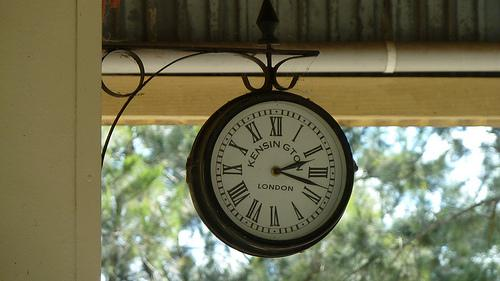Can you count how many objects are at the scene? What are they? There are 4 objects: a black clock with Roman numerals, a white wall, a white pipe, and green leaves in the background. What type of clock is in the image, and what is its color? It's a black clock with Roman numerals and "Kensington London" written on it. Describe the scene around the clock. There is a white wall with a wood beam, a hanging clock with roman numerals, a white pipe against the wall, and a forest area with green leaves in the background. What is the color of the wall, and what object is leaning against it? The wall is white, and a white pipe is leaning against it. Explain the position and characteristics of the clock's hands. The clock has black hands, with a small hour handle and a large minute handle. Identify the type of numeral system used on the clock. The clock uses Roman numerals. Provide a description of the primary object in the image. A black clock with roman numerals and "Kensington London" written on it is hanging on a white wall. What is unusual about the numbers on the clock and their placement? They are Roman numerals, and they are not placed in a perfect circle. How does the clock appear to be attached to the wall? The clock is attached to the wall using a metal display arm. Where are the green leaves located? The green leaves are located in the forest area in the background of the image. Describe the type of clock in the image. A hanging clock What is the color combination of the clock? Brown and white Identify the color of the leaves in the background. Green Can you see a digital clock in the image? The image describes a clock with roman numerals, which means it is an analog clock. Mentioning a digital clock is misleading. Can you find any animals in the forest area of the image? No, it's not mentioned in the image. Describe the color and type of numerals on the clock. The clock has black Roman numerals. Which objects are found against the wall? A clock and a white pipe How many clock hands are mentioned in the image captions? Two (little hand and big hand) List the different types of numerals mentioned on the clock face. XII, VI, III, IX, X In the image, where is the clock positioned? Attached to the wall Describe the wall where the clock is hanging. The wall is white. Which part of the clock is made of metal? Clock display arm What does the clock say? Kensington London What type of hands does the clock have? Provide a brief description. The clock has a small hour hand and a large minute hand, both black. Describe the clock's appearance. It is a black and white clock with Roman numerals, hanging on a white wall. The hands are black and it says Kensington London. Describe the surroundings of the clock in the image. A white wall, a wood beam, and a forest area with green leaves. What is unique about the numerals on the clock? The numerals are Roman. Provide a brief description of the forest area in the background of the image. The forest area has green leaves. Which statement is true about the clock? b) The clock is white  What type of numeral represents 3 on the clock face? III What type of numerals does the clock have? Roman numerals 